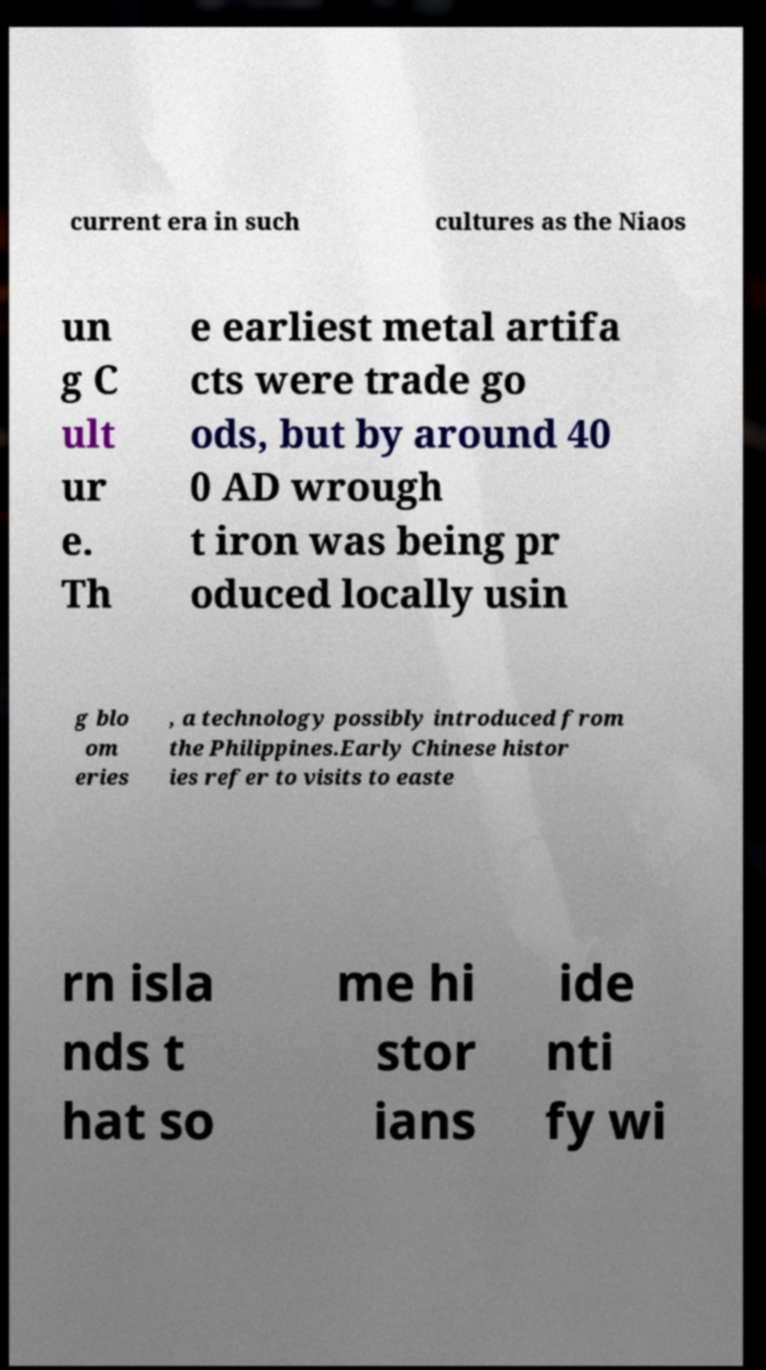What messages or text are displayed in this image? I need them in a readable, typed format. current era in such cultures as the Niaos un g C ult ur e. Th e earliest metal artifa cts were trade go ods, but by around 40 0 AD wrough t iron was being pr oduced locally usin g blo om eries , a technology possibly introduced from the Philippines.Early Chinese histor ies refer to visits to easte rn isla nds t hat so me hi stor ians ide nti fy wi 